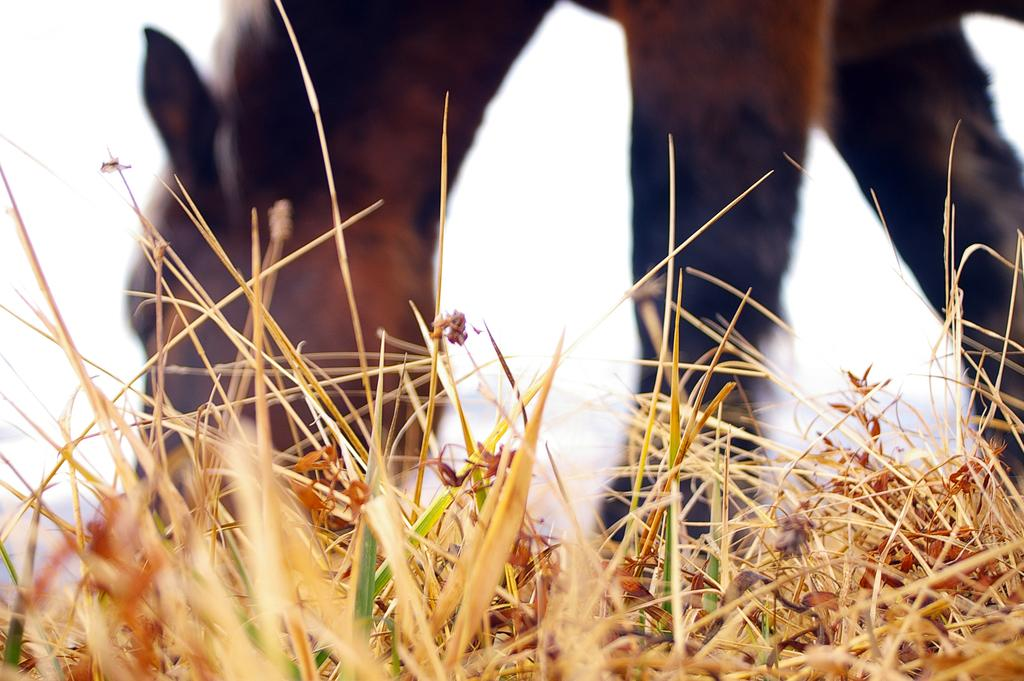What type of animal is standing in the image? The specific type of animal cannot be determined from the provided facts. What is the ground made of in the image? There is grass at the bottom of the image. What is visible at the top of the image? The sky is visible at the top of the image. How many eggs are being used to fuel the animal in the image? There is no indication in the image that the animal is being fueled by eggs or any other substance. 